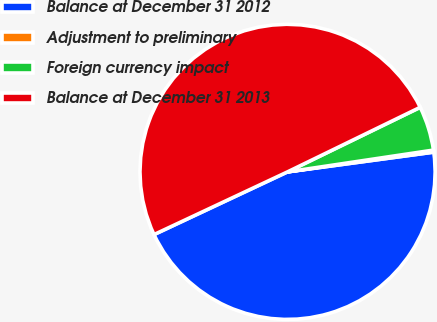<chart> <loc_0><loc_0><loc_500><loc_500><pie_chart><fcel>Balance at December 31 2012<fcel>Adjustment to preliminary<fcel>Foreign currency impact<fcel>Balance at December 31 2013<nl><fcel>45.15%<fcel>0.22%<fcel>4.85%<fcel>49.78%<nl></chart> 